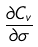Convert formula to latex. <formula><loc_0><loc_0><loc_500><loc_500>\frac { \partial C _ { v } } { \partial \sigma }</formula> 